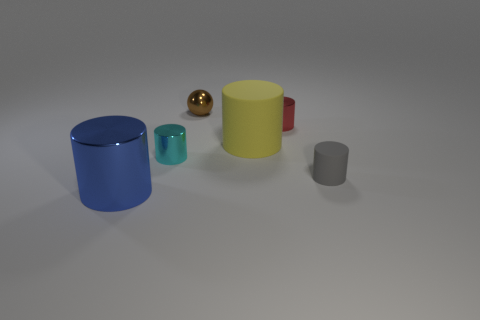Can you describe the lighting in the scene? The scene is softly lit, likely with a diffused light source coming from above, as indicated by the gentle shadows directly beneath the objects. There are no harsh highlights or strong directional shadows, so the overall ambiance is quite even and calm, suggesting either an overcast day or indoor lighting from a wide light source. 